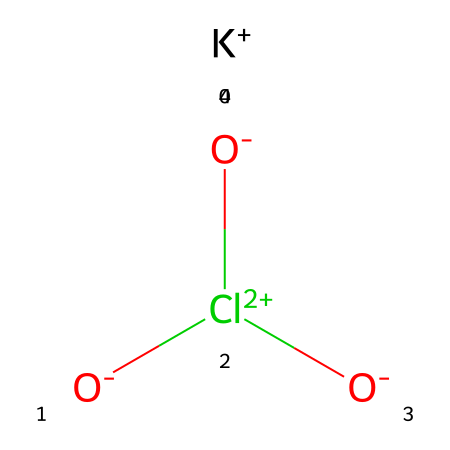What is the chemical name of the structure represented? The SMILES notation corresponds to potassium chlorate, which is a compound containing potassium, chlorine, and oxygen. The structure reveals the presence of chlorate ion \(ClO_3^-\) paired with a potassium ion \(K^+\).
Answer: potassium chlorate How many oxygen atoms are present in this compound? By analyzing the structure, the chlorate ion \(ClO_3^-\) indicates there are three oxygen atoms associated with chlorine. Therefore, the total count of oxygen atoms in this compound is three.
Answer: 3 What type of ion is represented by "K+" in this structure? The "K+" denotes a cation, which is a positively charged ion. It indicates that potassium has lost one electron, resulting in a positive charge, which is typical for alkali metals like potassium.
Answer: cation What is the oxidation state of chlorine in potassium chlorate? The oxidation state of chlorine can be determined by considering the chlorate ion \(ClO_3^-\). The overall charge of the ion is -1, and knowing that each oxygen typically has an oxidation state of -2 results in chlorine having an oxidation state of +5 to balance the charges.
Answer: +5 Does potassium chlorate act as an oxidizer? Yes, potassium chlorate is known to be a strong oxidizer. This is attributed to the high oxidation state of chlorine and the presence of oxygen in the compound, which enables it to facilitate reactions involving electron transfer.
Answer: yes 